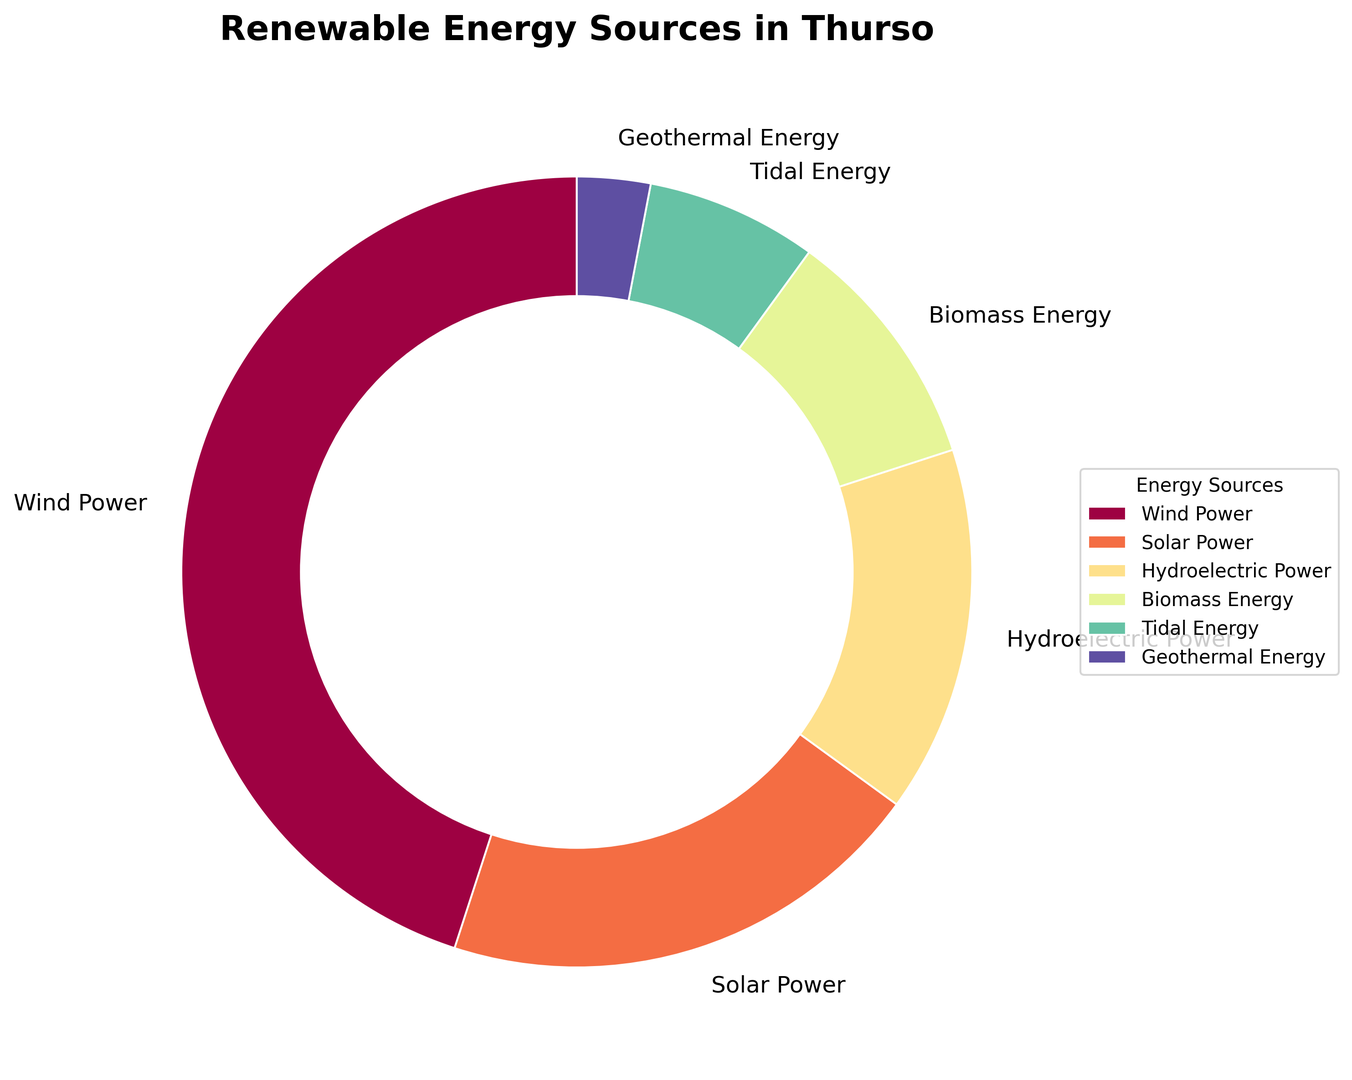What's the percentage of Wind Power in the renewable energy sources used in Thurso? Look at the section labeled "Wind Power" in the pie chart, and note the percentage written there.
Answer: 45% Which renewable energy source contributes the least? Compare the percentages of all sources in the pie chart to see which one has the smallest value. Geothermal Energy has the smallest percentage.
Answer: Geothermal Energy What's the sum of the percentages for Solar Power and Tidal Energy? Add the percentages for Solar Power (20%) and Tidal Energy (7%) from the pie chart. 20% + 7% = 27%
Answer: 27% Is the contribution of Biomass Energy greater than that of Hydroelectric Power? Compare the percentages of Biomass Energy (10%) and Hydroelectric Power (15%) from the pie chart. Biomass Energy (10%) is less than Hydroelectric Power (15%).
Answer: No Which energy source is represented by a larger slice: Solar Power or Biomass Energy? Find the percentages for Solar Power (20%) and Biomass Energy (10%) on the pie chart, then compare their sizes.
Answer: Solar Power What does the size of the wedge for Wind Power indicate as compared to all other sources combined? Wind Power has a percentage of 45%. All other sources combined would be 100% - 45% = 55%. Wind Power covers almost half of the pie chart, indicating its major contribution.
Answer: Wind Power is the largest contributor Are there any sources whose combined contribution is equal to Wind Power? If yes, which ones? Find combinations of sources where their total percentage equals Wind Power (45%). Solar Power (20%) + Hydroelectric Power (15%) + Biomass Energy (10%) = 45%.
Answer: Solar Power, Hydroelectric Power, Biomass Energy What percentage of renewable energy sources is contributed by sources other than Wind and Solar Power? Subtract the sum of Wind Power (45%) and Solar Power (20%) from 100%. 100% - 45% - 20% = 35%.
Answer: 35% Which energy source contributes more, Tidal or Biomass Energy? Compare the percentages of Tidal Energy (7%) and Biomass Energy (10%) on the pie chart. Biomass Energy is larger.
Answer: Biomass Energy How many sources contribute less than 10% to the total renewable energy? Identify the sources with percentages less than 10% from the pie chart: Tidal Energy (7%) and Geothermal Energy (3%). Count these sources.
Answer: 2 